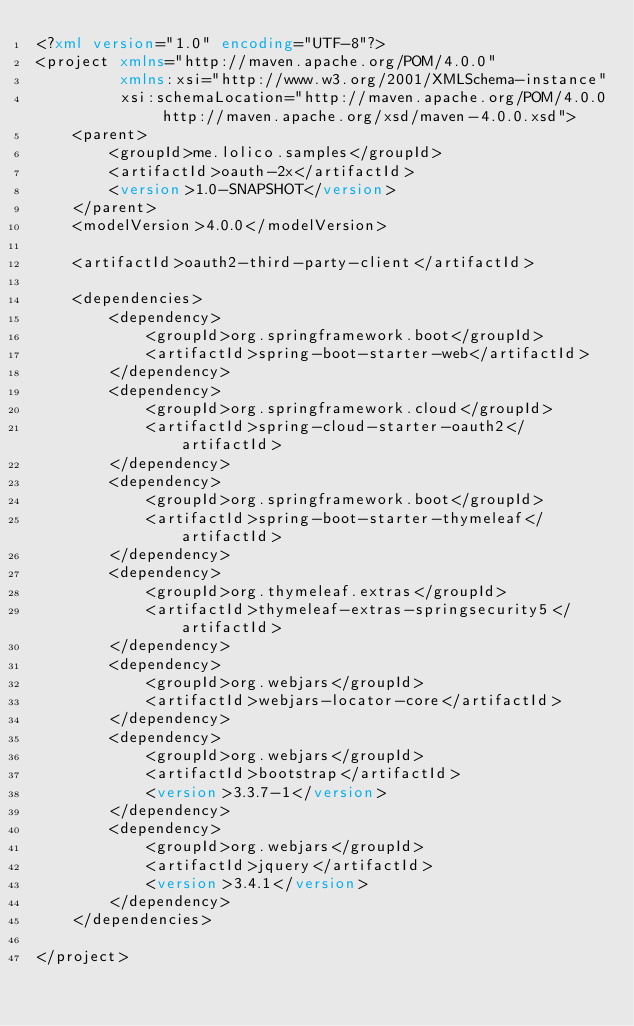Convert code to text. <code><loc_0><loc_0><loc_500><loc_500><_XML_><?xml version="1.0" encoding="UTF-8"?>
<project xmlns="http://maven.apache.org/POM/4.0.0"
         xmlns:xsi="http://www.w3.org/2001/XMLSchema-instance"
         xsi:schemaLocation="http://maven.apache.org/POM/4.0.0 http://maven.apache.org/xsd/maven-4.0.0.xsd">
    <parent>
        <groupId>me.lolico.samples</groupId>
        <artifactId>oauth-2x</artifactId>
        <version>1.0-SNAPSHOT</version>
    </parent>
    <modelVersion>4.0.0</modelVersion>

    <artifactId>oauth2-third-party-client</artifactId>

    <dependencies>
        <dependency>
            <groupId>org.springframework.boot</groupId>
            <artifactId>spring-boot-starter-web</artifactId>
        </dependency>
        <dependency>
            <groupId>org.springframework.cloud</groupId>
            <artifactId>spring-cloud-starter-oauth2</artifactId>
        </dependency>
        <dependency>
            <groupId>org.springframework.boot</groupId>
            <artifactId>spring-boot-starter-thymeleaf</artifactId>
        </dependency>
        <dependency>
            <groupId>org.thymeleaf.extras</groupId>
            <artifactId>thymeleaf-extras-springsecurity5</artifactId>
        </dependency>
        <dependency>
            <groupId>org.webjars</groupId>
            <artifactId>webjars-locator-core</artifactId>
        </dependency>
        <dependency>
            <groupId>org.webjars</groupId>
            <artifactId>bootstrap</artifactId>
            <version>3.3.7-1</version>
        </dependency>
        <dependency>
            <groupId>org.webjars</groupId>
            <artifactId>jquery</artifactId>
            <version>3.4.1</version>
        </dependency>
    </dependencies>

</project>
</code> 